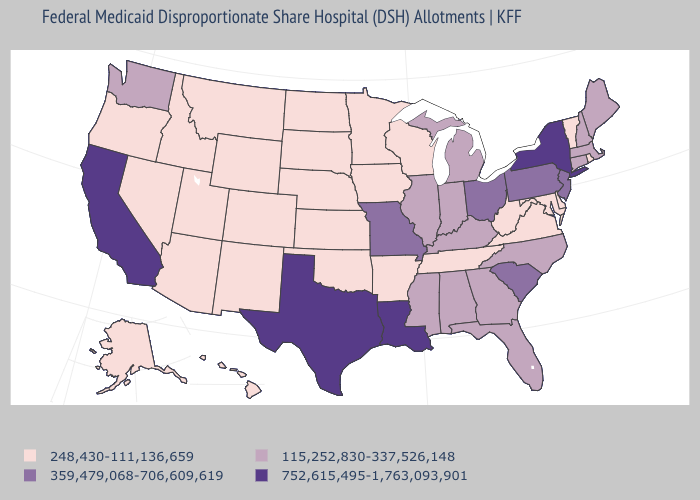Does Nebraska have the lowest value in the USA?
Write a very short answer. Yes. What is the highest value in the South ?
Write a very short answer. 752,615,495-1,763,093,901. What is the value of New Jersey?
Write a very short answer. 359,479,068-706,609,619. What is the value of South Carolina?
Quick response, please. 359,479,068-706,609,619. What is the value of Utah?
Concise answer only. 248,430-111,136,659. What is the lowest value in the West?
Short answer required. 248,430-111,136,659. Name the states that have a value in the range 115,252,830-337,526,148?
Be succinct. Alabama, Connecticut, Florida, Georgia, Illinois, Indiana, Kentucky, Maine, Massachusetts, Michigan, Mississippi, New Hampshire, North Carolina, Washington. Name the states that have a value in the range 248,430-111,136,659?
Be succinct. Alaska, Arizona, Arkansas, Colorado, Delaware, Hawaii, Idaho, Iowa, Kansas, Maryland, Minnesota, Montana, Nebraska, Nevada, New Mexico, North Dakota, Oklahoma, Oregon, Rhode Island, South Dakota, Tennessee, Utah, Vermont, Virginia, West Virginia, Wisconsin, Wyoming. Name the states that have a value in the range 248,430-111,136,659?
Quick response, please. Alaska, Arizona, Arkansas, Colorado, Delaware, Hawaii, Idaho, Iowa, Kansas, Maryland, Minnesota, Montana, Nebraska, Nevada, New Mexico, North Dakota, Oklahoma, Oregon, Rhode Island, South Dakota, Tennessee, Utah, Vermont, Virginia, West Virginia, Wisconsin, Wyoming. Is the legend a continuous bar?
Concise answer only. No. Name the states that have a value in the range 752,615,495-1,763,093,901?
Write a very short answer. California, Louisiana, New York, Texas. Name the states that have a value in the range 752,615,495-1,763,093,901?
Give a very brief answer. California, Louisiana, New York, Texas. Which states have the highest value in the USA?
Write a very short answer. California, Louisiana, New York, Texas. Does the map have missing data?
Write a very short answer. No. 